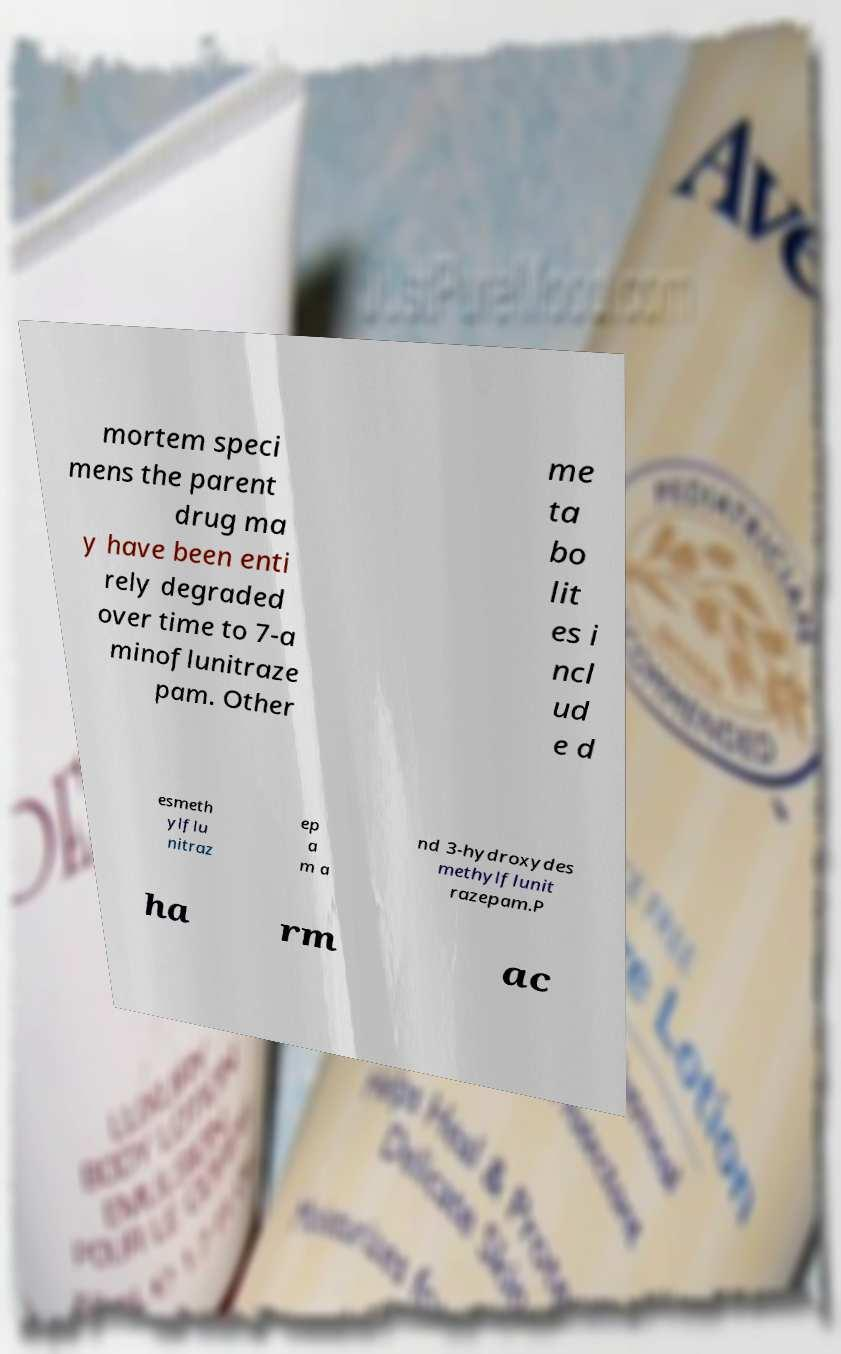Please read and relay the text visible in this image. What does it say? mortem speci mens the parent drug ma y have been enti rely degraded over time to 7-a minoflunitraze pam. Other me ta bo lit es i ncl ud e d esmeth ylflu nitraz ep a m a nd 3-hydroxydes methylflunit razepam.P ha rm ac 